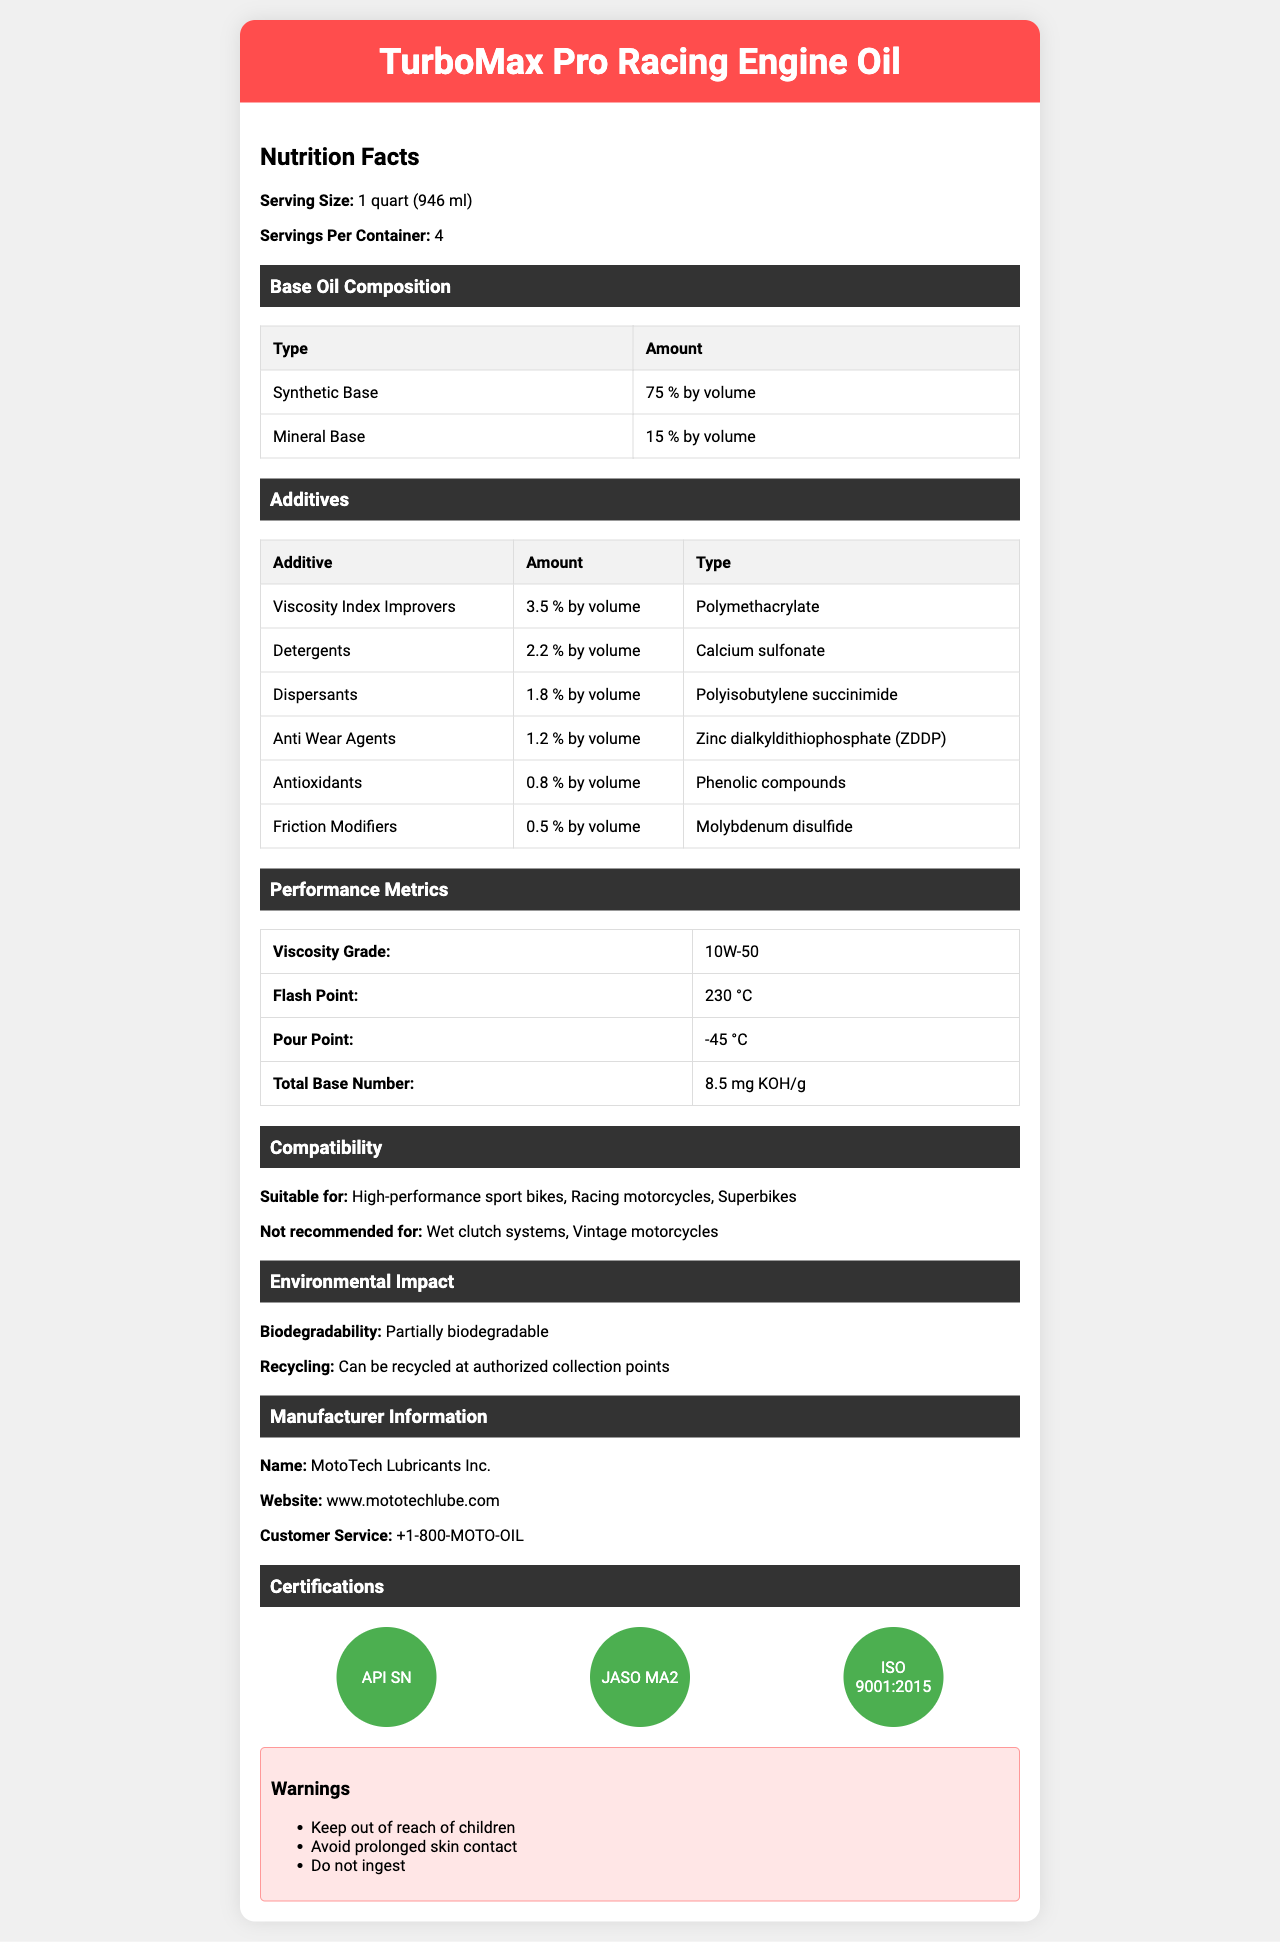what is the product name? The product name is clearly listed at the beginning of the document.
Answer: TurboMax Pro Racing Engine Oil what is the serving size for the engine oil? The serving size is specified as 1 quart (946 ml) under the Nutrition Facts section.
Answer: 1 quart (946 ml) How many servings are there per container? The document states that there are 4 servings per container.
Answer: 4 What is the amount of synthetic base oil in the product by volume? The percentage of synthetic base oil by volume is listed as 75% under the Base Oil Composition section.
Answer: 75% What is the amount of mineral base oil in the product by volume? The percentage of mineral base oil by volume is listed as 15% under the Base Oil Composition section.
Answer: 15% what is the viscosity grade of this engine oil? The Performance Metrics table shows that the viscosity grade of the engine oil is 10W-50.
Answer: 10W-50 what type of friction modifier is used in the oil? The Additives section specifies that the friction modifier used is Molybdenum disulfide.
Answer: Molybdenum disulfide which certification is not mentioned in the document? A. API SN B. JASO MA2 C. ISO 9001:2015 D. ACEA The document lists only API SN, JASO MA2, and ISO 9001:2015 certifications. ACEA is not mentioned.
Answer: D What are the recommended uses of this engine oil? A. Wet clutch systems B. Vintage motorcycles C. High-performance sport bikes D. Standard motorcycles The document states that the oil is suitable for high-performance sport bikes and does not recommend it for wet clutch systems or vintage motorcycles.
Answer: C Is the engine oil biodegradable? The Environmental Impact section states that the oil is partially biodegradable.
Answer: Partially biodegradable Is the engine oil suitable for vintage motorcycles? The Compatibility section explicitly mentions that the oil is not recommended for vintage motorcycles.
Answer: No describe the main content of the document. The document starts with the product name and serving size, followed by sections on the base oil composition and various additives. It also includes performance metrics like viscosity grade and compatibility recommendations. The environmental impact, manufacturer details, certifications, and warnings are also covered.
Answer: This document provides detailed information about TurboMax Pro Racing Engine Oil, including its composition, additives, performance metrics, compatibility, environmental impact, manufacturer information, certifications, and warnings. What is the total cost of the engine oil? The document does not provide any information about the cost or price of the engine oil.
Answer: Not enough information 